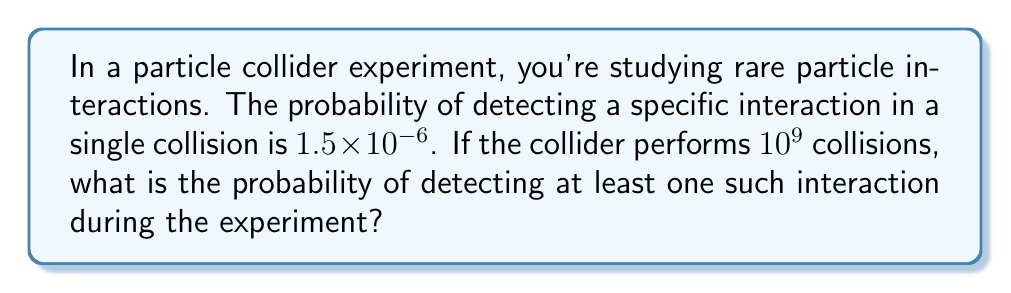Can you solve this math problem? Let's approach this step-by-step:

1) First, let's define our events:
   Let A be the event of detecting the specific interaction in a single collision.
   
2) We're given:
   $P(A) = 1.5 \times 10^{-6}$
   Number of collisions, $n = 10^9$

3) We want to find the probability of detecting at least one interaction in $n$ collisions.
   This is equivalent to 1 minus the probability of detecting no interactions in $n$ collisions.

4) The probability of not detecting the interaction in a single collision is:
   $P(\text{not } A) = 1 - P(A) = 1 - (1.5 \times 10^{-6}) = 0.9999985$

5) For $n$ independent collisions, the probability of not detecting the interaction in any of them is:
   $P(\text{no detection in } n \text{ collisions}) = (0.9999985)^{10^9}$

6) Therefore, the probability of detecting at least one interaction is:
   $P(\text{at least one detection}) = 1 - (0.9999985)^{10^9}$

7) Using a calculator or computer (as this involves very small numbers):
   $1 - (0.9999985)^{10^9} \approx 0.7768698$

8) Converting to a percentage: $0.7768698 \times 100\% \approx 77.69\%$
Answer: $77.69\%$ 